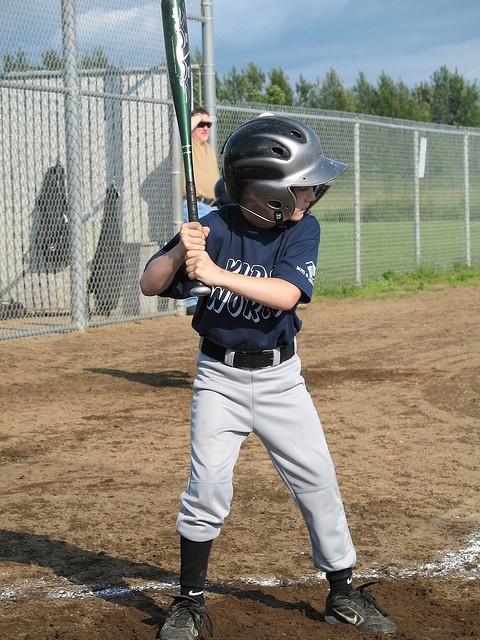Describe the objects in this image and their specific colors. I can see people in darkgray, black, lightgray, and gray tones, baseball bat in darkgray, black, gray, white, and teal tones, and people in darkgray, tan, black, and lightgray tones in this image. 